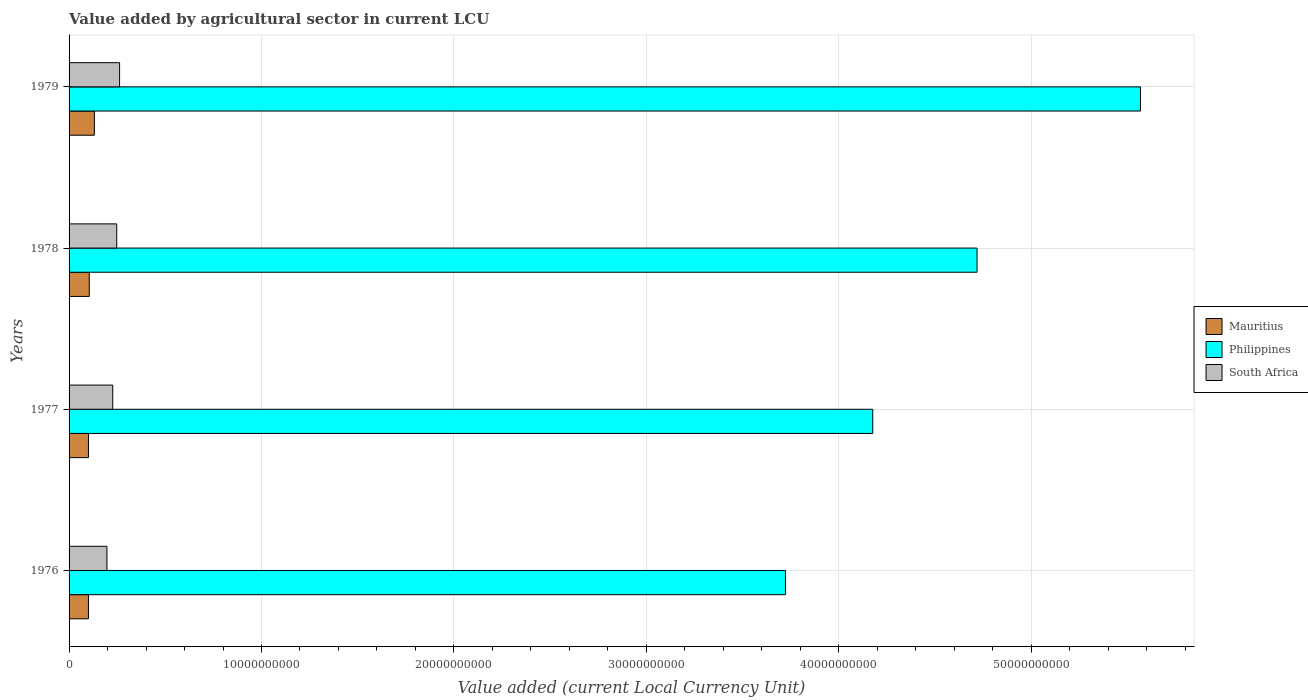How many bars are there on the 2nd tick from the top?
Your answer should be compact. 3. What is the label of the 3rd group of bars from the top?
Provide a short and direct response. 1977. In how many cases, is the number of bars for a given year not equal to the number of legend labels?
Make the answer very short. 0. What is the value added by agricultural sector in Philippines in 1976?
Provide a short and direct response. 3.72e+1. Across all years, what is the maximum value added by agricultural sector in South Africa?
Keep it short and to the point. 2.63e+09. Across all years, what is the minimum value added by agricultural sector in Mauritius?
Keep it short and to the point. 1.01e+09. In which year was the value added by agricultural sector in Mauritius maximum?
Keep it short and to the point. 1979. In which year was the value added by agricultural sector in South Africa minimum?
Ensure brevity in your answer.  1976. What is the total value added by agricultural sector in South Africa in the graph?
Make the answer very short. 9.34e+09. What is the difference between the value added by agricultural sector in Philippines in 1976 and that in 1978?
Offer a terse response. -9.96e+09. What is the difference between the value added by agricultural sector in Mauritius in 1979 and the value added by agricultural sector in South Africa in 1976?
Ensure brevity in your answer.  -6.53e+08. What is the average value added by agricultural sector in Mauritius per year?
Your response must be concise. 1.09e+09. In the year 1977, what is the difference between the value added by agricultural sector in Mauritius and value added by agricultural sector in South Africa?
Offer a terse response. -1.26e+09. In how many years, is the value added by agricultural sector in Philippines greater than 40000000000 LCU?
Provide a short and direct response. 3. What is the ratio of the value added by agricultural sector in Philippines in 1976 to that in 1978?
Provide a succinct answer. 0.79. Is the difference between the value added by agricultural sector in Mauritius in 1976 and 1978 greater than the difference between the value added by agricultural sector in South Africa in 1976 and 1978?
Keep it short and to the point. Yes. What is the difference between the highest and the second highest value added by agricultural sector in Philippines?
Offer a very short reply. 8.49e+09. What is the difference between the highest and the lowest value added by agricultural sector in Mauritius?
Ensure brevity in your answer.  3.07e+08. What does the 1st bar from the top in 1979 represents?
Make the answer very short. South Africa. What does the 3rd bar from the bottom in 1979 represents?
Your answer should be very brief. South Africa. Are all the bars in the graph horizontal?
Provide a short and direct response. Yes. How many years are there in the graph?
Provide a succinct answer. 4. What is the difference between two consecutive major ticks on the X-axis?
Give a very brief answer. 1.00e+1. Are the values on the major ticks of X-axis written in scientific E-notation?
Provide a succinct answer. No. Does the graph contain grids?
Offer a terse response. Yes. How are the legend labels stacked?
Offer a terse response. Vertical. What is the title of the graph?
Your answer should be very brief. Value added by agricultural sector in current LCU. Does "Egypt, Arab Rep." appear as one of the legend labels in the graph?
Offer a terse response. No. What is the label or title of the X-axis?
Your response must be concise. Value added (current Local Currency Unit). What is the label or title of the Y-axis?
Offer a terse response. Years. What is the Value added (current Local Currency Unit) in Mauritius in 1976?
Provide a short and direct response. 1.01e+09. What is the Value added (current Local Currency Unit) in Philippines in 1976?
Provide a short and direct response. 3.72e+1. What is the Value added (current Local Currency Unit) in South Africa in 1976?
Your answer should be compact. 1.97e+09. What is the Value added (current Local Currency Unit) in Mauritius in 1977?
Your response must be concise. 1.01e+09. What is the Value added (current Local Currency Unit) in Philippines in 1977?
Ensure brevity in your answer.  4.18e+1. What is the Value added (current Local Currency Unit) in South Africa in 1977?
Provide a short and direct response. 2.27e+09. What is the Value added (current Local Currency Unit) in Mauritius in 1978?
Ensure brevity in your answer.  1.05e+09. What is the Value added (current Local Currency Unit) of Philippines in 1978?
Ensure brevity in your answer.  4.72e+1. What is the Value added (current Local Currency Unit) in South Africa in 1978?
Ensure brevity in your answer.  2.48e+09. What is the Value added (current Local Currency Unit) of Mauritius in 1979?
Your response must be concise. 1.31e+09. What is the Value added (current Local Currency Unit) in Philippines in 1979?
Make the answer very short. 5.57e+1. What is the Value added (current Local Currency Unit) in South Africa in 1979?
Your response must be concise. 2.63e+09. Across all years, what is the maximum Value added (current Local Currency Unit) in Mauritius?
Offer a very short reply. 1.31e+09. Across all years, what is the maximum Value added (current Local Currency Unit) of Philippines?
Provide a short and direct response. 5.57e+1. Across all years, what is the maximum Value added (current Local Currency Unit) in South Africa?
Ensure brevity in your answer.  2.63e+09. Across all years, what is the minimum Value added (current Local Currency Unit) in Mauritius?
Provide a succinct answer. 1.01e+09. Across all years, what is the minimum Value added (current Local Currency Unit) of Philippines?
Offer a terse response. 3.72e+1. Across all years, what is the minimum Value added (current Local Currency Unit) of South Africa?
Make the answer very short. 1.97e+09. What is the total Value added (current Local Currency Unit) of Mauritius in the graph?
Give a very brief answer. 4.38e+09. What is the total Value added (current Local Currency Unit) in Philippines in the graph?
Your response must be concise. 1.82e+11. What is the total Value added (current Local Currency Unit) in South Africa in the graph?
Make the answer very short. 9.34e+09. What is the difference between the Value added (current Local Currency Unit) in Mauritius in 1976 and that in 1977?
Offer a terse response. -1.07e+06. What is the difference between the Value added (current Local Currency Unit) of Philippines in 1976 and that in 1977?
Your answer should be very brief. -4.54e+09. What is the difference between the Value added (current Local Currency Unit) of South Africa in 1976 and that in 1977?
Provide a short and direct response. -3.01e+08. What is the difference between the Value added (current Local Currency Unit) in Mauritius in 1976 and that in 1978?
Provide a short and direct response. -4.19e+07. What is the difference between the Value added (current Local Currency Unit) of Philippines in 1976 and that in 1978?
Give a very brief answer. -9.96e+09. What is the difference between the Value added (current Local Currency Unit) in South Africa in 1976 and that in 1978?
Make the answer very short. -5.10e+08. What is the difference between the Value added (current Local Currency Unit) in Mauritius in 1976 and that in 1979?
Your answer should be compact. -3.07e+08. What is the difference between the Value added (current Local Currency Unit) of Philippines in 1976 and that in 1979?
Provide a short and direct response. -1.85e+1. What is the difference between the Value added (current Local Currency Unit) in South Africa in 1976 and that in 1979?
Give a very brief answer. -6.58e+08. What is the difference between the Value added (current Local Currency Unit) in Mauritius in 1977 and that in 1978?
Keep it short and to the point. -4.08e+07. What is the difference between the Value added (current Local Currency Unit) in Philippines in 1977 and that in 1978?
Your response must be concise. -5.42e+09. What is the difference between the Value added (current Local Currency Unit) of South Africa in 1977 and that in 1978?
Make the answer very short. -2.09e+08. What is the difference between the Value added (current Local Currency Unit) of Mauritius in 1977 and that in 1979?
Give a very brief answer. -3.06e+08. What is the difference between the Value added (current Local Currency Unit) of Philippines in 1977 and that in 1979?
Ensure brevity in your answer.  -1.39e+1. What is the difference between the Value added (current Local Currency Unit) of South Africa in 1977 and that in 1979?
Your response must be concise. -3.57e+08. What is the difference between the Value added (current Local Currency Unit) in Mauritius in 1978 and that in 1979?
Ensure brevity in your answer.  -2.65e+08. What is the difference between the Value added (current Local Currency Unit) in Philippines in 1978 and that in 1979?
Your answer should be compact. -8.49e+09. What is the difference between the Value added (current Local Currency Unit) of South Africa in 1978 and that in 1979?
Your answer should be very brief. -1.48e+08. What is the difference between the Value added (current Local Currency Unit) of Mauritius in 1976 and the Value added (current Local Currency Unit) of Philippines in 1977?
Keep it short and to the point. -4.08e+1. What is the difference between the Value added (current Local Currency Unit) of Mauritius in 1976 and the Value added (current Local Currency Unit) of South Africa in 1977?
Ensure brevity in your answer.  -1.26e+09. What is the difference between the Value added (current Local Currency Unit) of Philippines in 1976 and the Value added (current Local Currency Unit) of South Africa in 1977?
Your answer should be compact. 3.50e+1. What is the difference between the Value added (current Local Currency Unit) in Mauritius in 1976 and the Value added (current Local Currency Unit) in Philippines in 1978?
Give a very brief answer. -4.62e+1. What is the difference between the Value added (current Local Currency Unit) in Mauritius in 1976 and the Value added (current Local Currency Unit) in South Africa in 1978?
Keep it short and to the point. -1.47e+09. What is the difference between the Value added (current Local Currency Unit) in Philippines in 1976 and the Value added (current Local Currency Unit) in South Africa in 1978?
Provide a succinct answer. 3.48e+1. What is the difference between the Value added (current Local Currency Unit) in Mauritius in 1976 and the Value added (current Local Currency Unit) in Philippines in 1979?
Give a very brief answer. -5.47e+1. What is the difference between the Value added (current Local Currency Unit) of Mauritius in 1976 and the Value added (current Local Currency Unit) of South Africa in 1979?
Provide a succinct answer. -1.62e+09. What is the difference between the Value added (current Local Currency Unit) in Philippines in 1976 and the Value added (current Local Currency Unit) in South Africa in 1979?
Your answer should be compact. 3.46e+1. What is the difference between the Value added (current Local Currency Unit) of Mauritius in 1977 and the Value added (current Local Currency Unit) of Philippines in 1978?
Offer a very short reply. -4.62e+1. What is the difference between the Value added (current Local Currency Unit) in Mauritius in 1977 and the Value added (current Local Currency Unit) in South Africa in 1978?
Your answer should be very brief. -1.47e+09. What is the difference between the Value added (current Local Currency Unit) of Philippines in 1977 and the Value added (current Local Currency Unit) of South Africa in 1978?
Your answer should be very brief. 3.93e+1. What is the difference between the Value added (current Local Currency Unit) in Mauritius in 1977 and the Value added (current Local Currency Unit) in Philippines in 1979?
Provide a succinct answer. -5.47e+1. What is the difference between the Value added (current Local Currency Unit) of Mauritius in 1977 and the Value added (current Local Currency Unit) of South Africa in 1979?
Keep it short and to the point. -1.62e+09. What is the difference between the Value added (current Local Currency Unit) in Philippines in 1977 and the Value added (current Local Currency Unit) in South Africa in 1979?
Your response must be concise. 3.91e+1. What is the difference between the Value added (current Local Currency Unit) in Mauritius in 1978 and the Value added (current Local Currency Unit) in Philippines in 1979?
Your answer should be very brief. -5.46e+1. What is the difference between the Value added (current Local Currency Unit) of Mauritius in 1978 and the Value added (current Local Currency Unit) of South Africa in 1979?
Keep it short and to the point. -1.58e+09. What is the difference between the Value added (current Local Currency Unit) of Philippines in 1978 and the Value added (current Local Currency Unit) of South Africa in 1979?
Your answer should be compact. 4.46e+1. What is the average Value added (current Local Currency Unit) of Mauritius per year?
Offer a terse response. 1.09e+09. What is the average Value added (current Local Currency Unit) in Philippines per year?
Offer a very short reply. 4.55e+1. What is the average Value added (current Local Currency Unit) in South Africa per year?
Your response must be concise. 2.34e+09. In the year 1976, what is the difference between the Value added (current Local Currency Unit) in Mauritius and Value added (current Local Currency Unit) in Philippines?
Your response must be concise. -3.62e+1. In the year 1976, what is the difference between the Value added (current Local Currency Unit) in Mauritius and Value added (current Local Currency Unit) in South Africa?
Offer a terse response. -9.61e+08. In the year 1976, what is the difference between the Value added (current Local Currency Unit) in Philippines and Value added (current Local Currency Unit) in South Africa?
Your answer should be very brief. 3.53e+1. In the year 1977, what is the difference between the Value added (current Local Currency Unit) in Mauritius and Value added (current Local Currency Unit) in Philippines?
Your answer should be compact. -4.08e+1. In the year 1977, what is the difference between the Value added (current Local Currency Unit) of Mauritius and Value added (current Local Currency Unit) of South Africa?
Your response must be concise. -1.26e+09. In the year 1977, what is the difference between the Value added (current Local Currency Unit) in Philippines and Value added (current Local Currency Unit) in South Africa?
Keep it short and to the point. 3.95e+1. In the year 1978, what is the difference between the Value added (current Local Currency Unit) in Mauritius and Value added (current Local Currency Unit) in Philippines?
Your answer should be very brief. -4.61e+1. In the year 1978, what is the difference between the Value added (current Local Currency Unit) of Mauritius and Value added (current Local Currency Unit) of South Africa?
Provide a succinct answer. -1.43e+09. In the year 1978, what is the difference between the Value added (current Local Currency Unit) in Philippines and Value added (current Local Currency Unit) in South Africa?
Provide a succinct answer. 4.47e+1. In the year 1979, what is the difference between the Value added (current Local Currency Unit) of Mauritius and Value added (current Local Currency Unit) of Philippines?
Offer a terse response. -5.44e+1. In the year 1979, what is the difference between the Value added (current Local Currency Unit) of Mauritius and Value added (current Local Currency Unit) of South Africa?
Provide a succinct answer. -1.31e+09. In the year 1979, what is the difference between the Value added (current Local Currency Unit) in Philippines and Value added (current Local Currency Unit) in South Africa?
Your answer should be compact. 5.31e+1. What is the ratio of the Value added (current Local Currency Unit) in Mauritius in 1976 to that in 1977?
Offer a terse response. 1. What is the ratio of the Value added (current Local Currency Unit) in Philippines in 1976 to that in 1977?
Your answer should be very brief. 0.89. What is the ratio of the Value added (current Local Currency Unit) of South Africa in 1976 to that in 1977?
Provide a succinct answer. 0.87. What is the ratio of the Value added (current Local Currency Unit) of Mauritius in 1976 to that in 1978?
Give a very brief answer. 0.96. What is the ratio of the Value added (current Local Currency Unit) of Philippines in 1976 to that in 1978?
Your answer should be compact. 0.79. What is the ratio of the Value added (current Local Currency Unit) of South Africa in 1976 to that in 1978?
Ensure brevity in your answer.  0.79. What is the ratio of the Value added (current Local Currency Unit) in Mauritius in 1976 to that in 1979?
Make the answer very short. 0.77. What is the ratio of the Value added (current Local Currency Unit) of Philippines in 1976 to that in 1979?
Ensure brevity in your answer.  0.67. What is the ratio of the Value added (current Local Currency Unit) in South Africa in 1976 to that in 1979?
Keep it short and to the point. 0.75. What is the ratio of the Value added (current Local Currency Unit) in Mauritius in 1977 to that in 1978?
Provide a short and direct response. 0.96. What is the ratio of the Value added (current Local Currency Unit) in Philippines in 1977 to that in 1978?
Keep it short and to the point. 0.89. What is the ratio of the Value added (current Local Currency Unit) of South Africa in 1977 to that in 1978?
Provide a succinct answer. 0.92. What is the ratio of the Value added (current Local Currency Unit) in Mauritius in 1977 to that in 1979?
Give a very brief answer. 0.77. What is the ratio of the Value added (current Local Currency Unit) in Philippines in 1977 to that in 1979?
Make the answer very short. 0.75. What is the ratio of the Value added (current Local Currency Unit) of South Africa in 1977 to that in 1979?
Your answer should be compact. 0.86. What is the ratio of the Value added (current Local Currency Unit) of Mauritius in 1978 to that in 1979?
Your answer should be very brief. 0.8. What is the ratio of the Value added (current Local Currency Unit) of Philippines in 1978 to that in 1979?
Your response must be concise. 0.85. What is the ratio of the Value added (current Local Currency Unit) of South Africa in 1978 to that in 1979?
Make the answer very short. 0.94. What is the difference between the highest and the second highest Value added (current Local Currency Unit) of Mauritius?
Make the answer very short. 2.65e+08. What is the difference between the highest and the second highest Value added (current Local Currency Unit) in Philippines?
Your answer should be very brief. 8.49e+09. What is the difference between the highest and the second highest Value added (current Local Currency Unit) in South Africa?
Your response must be concise. 1.48e+08. What is the difference between the highest and the lowest Value added (current Local Currency Unit) in Mauritius?
Provide a short and direct response. 3.07e+08. What is the difference between the highest and the lowest Value added (current Local Currency Unit) in Philippines?
Provide a succinct answer. 1.85e+1. What is the difference between the highest and the lowest Value added (current Local Currency Unit) in South Africa?
Offer a very short reply. 6.58e+08. 